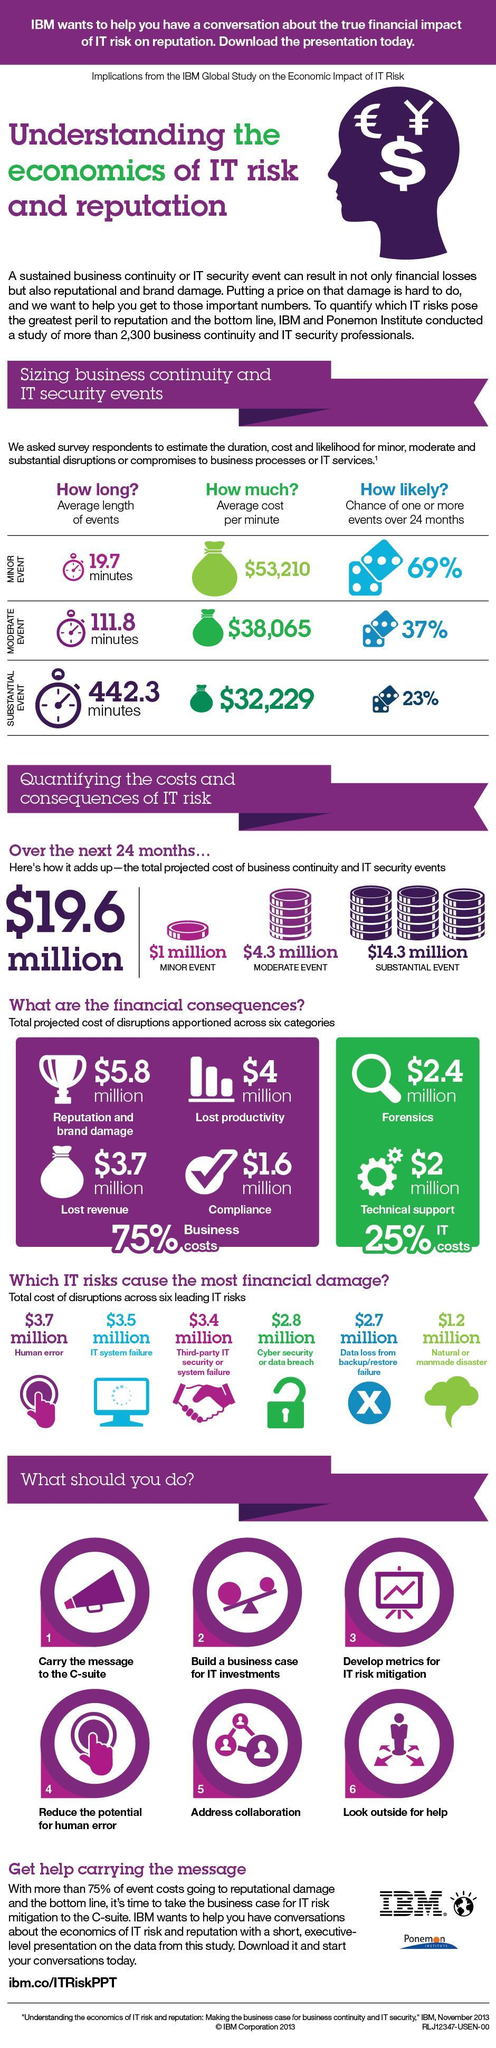What is the total cost of disruptions caused by IT system failure?
Answer the question with a short phrase. $3.5 million What is the percentage of one or more moderate events occurring over the next 24 months? 37% What is the total cost of disruptions caused by cyber security or data breach? $2.8 million What is the percentage of one or more minor events occurring over the next 24 months? 69% What is the total projected cost of disruptions apportioned across lost productivity? $4 million Which IT risks cause the least financial damage to the business? Natural or manmade disaster What is the average length of substantial events occurring over 24 months? 442.3 minutes What is the total projected cost of disruptions apportioned across lost revenue? $3.7 million Which IT risks cause the most financial damage to the business? Human error What is the total projected cost of disruptions apportioned across compliance? $1.6 million 